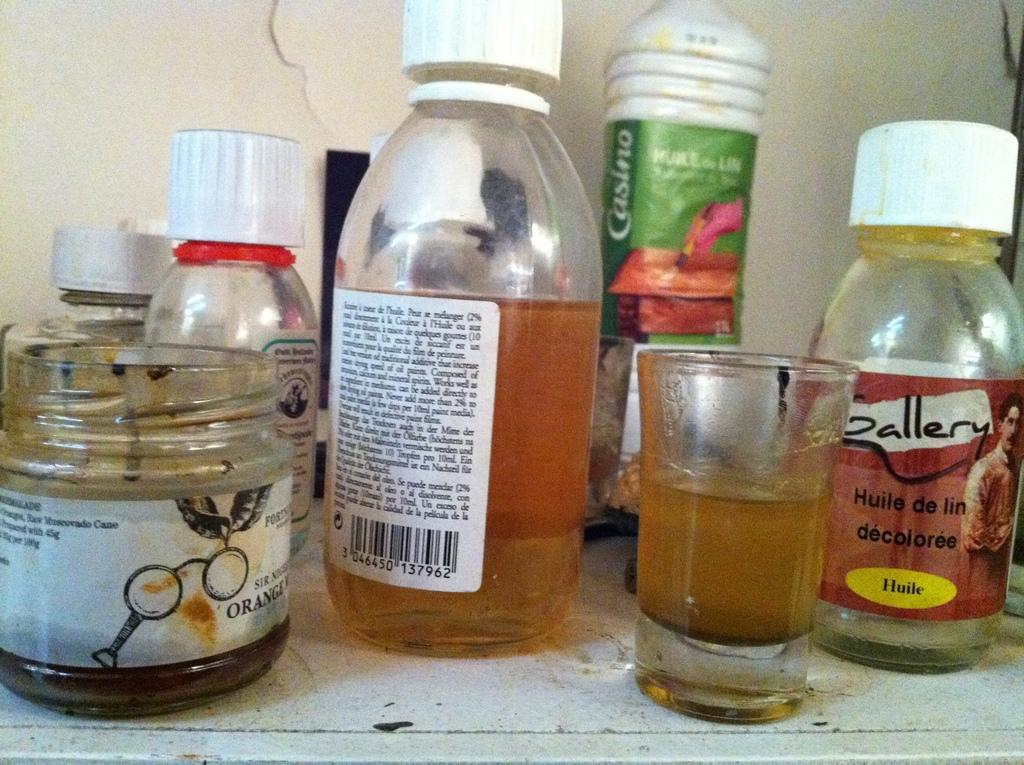<image>
Present a compact description of the photo's key features. A shot glass next to a bottle with a red label that says Gallery. 